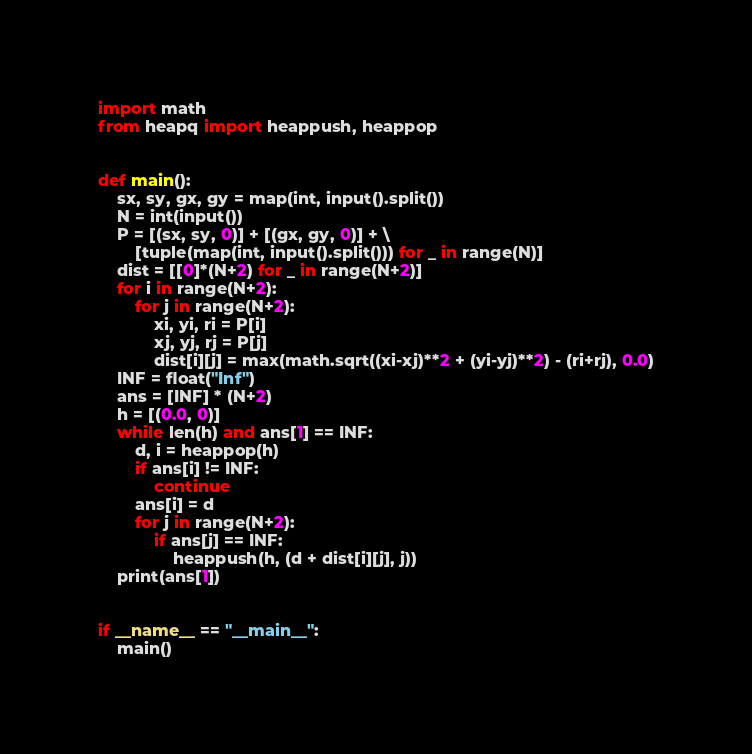Convert code to text. <code><loc_0><loc_0><loc_500><loc_500><_Python_>import math
from heapq import heappush, heappop


def main():
    sx, sy, gx, gy = map(int, input().split())
    N = int(input())
    P = [(sx, sy, 0)] + [(gx, gy, 0)] + \
        [tuple(map(int, input().split())) for _ in range(N)]
    dist = [[0]*(N+2) for _ in range(N+2)]
    for i in range(N+2):
        for j in range(N+2):
            xi, yi, ri = P[i]
            xj, yj, rj = P[j]
            dist[i][j] = max(math.sqrt((xi-xj)**2 + (yi-yj)**2) - (ri+rj), 0.0)
    INF = float("Inf")
    ans = [INF] * (N+2)
    h = [(0.0, 0)]
    while len(h) and ans[1] == INF:
        d, i = heappop(h)
        if ans[i] != INF:
            continue
        ans[i] = d
        for j in range(N+2):
            if ans[j] == INF:
                heappush(h, (d + dist[i][j], j))
    print(ans[1])


if __name__ == "__main__":
    main()
</code> 